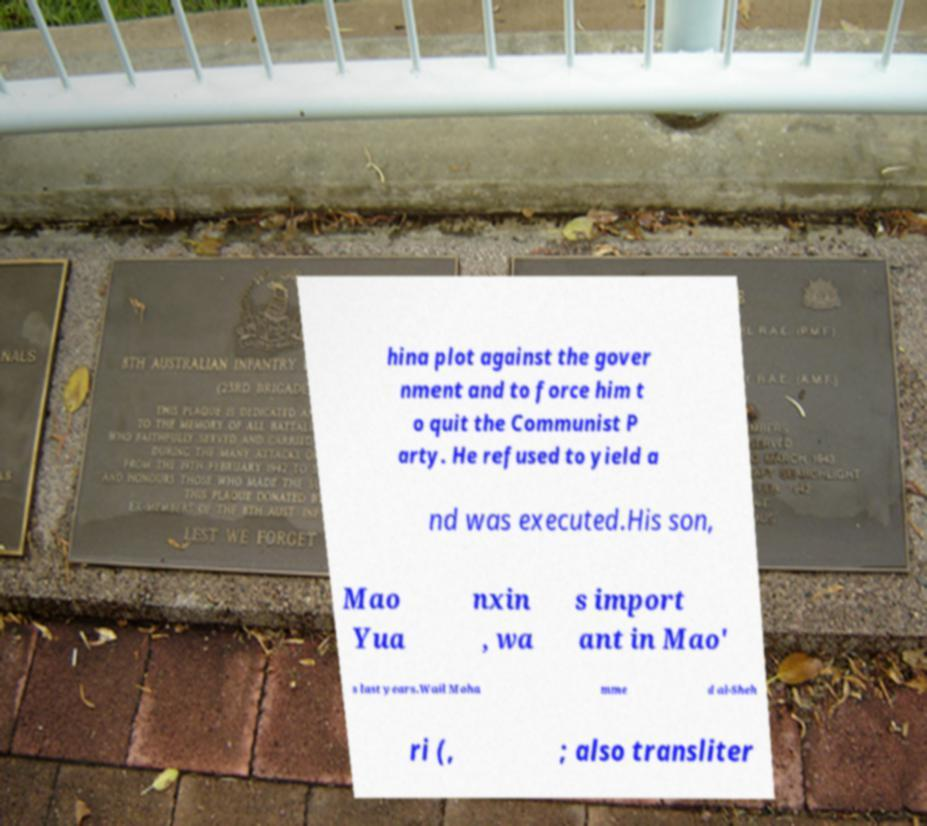Can you accurately transcribe the text from the provided image for me? hina plot against the gover nment and to force him t o quit the Communist P arty. He refused to yield a nd was executed.His son, Mao Yua nxin , wa s import ant in Mao' s last years.Wail Moha mme d al-Sheh ri (, ; also transliter 